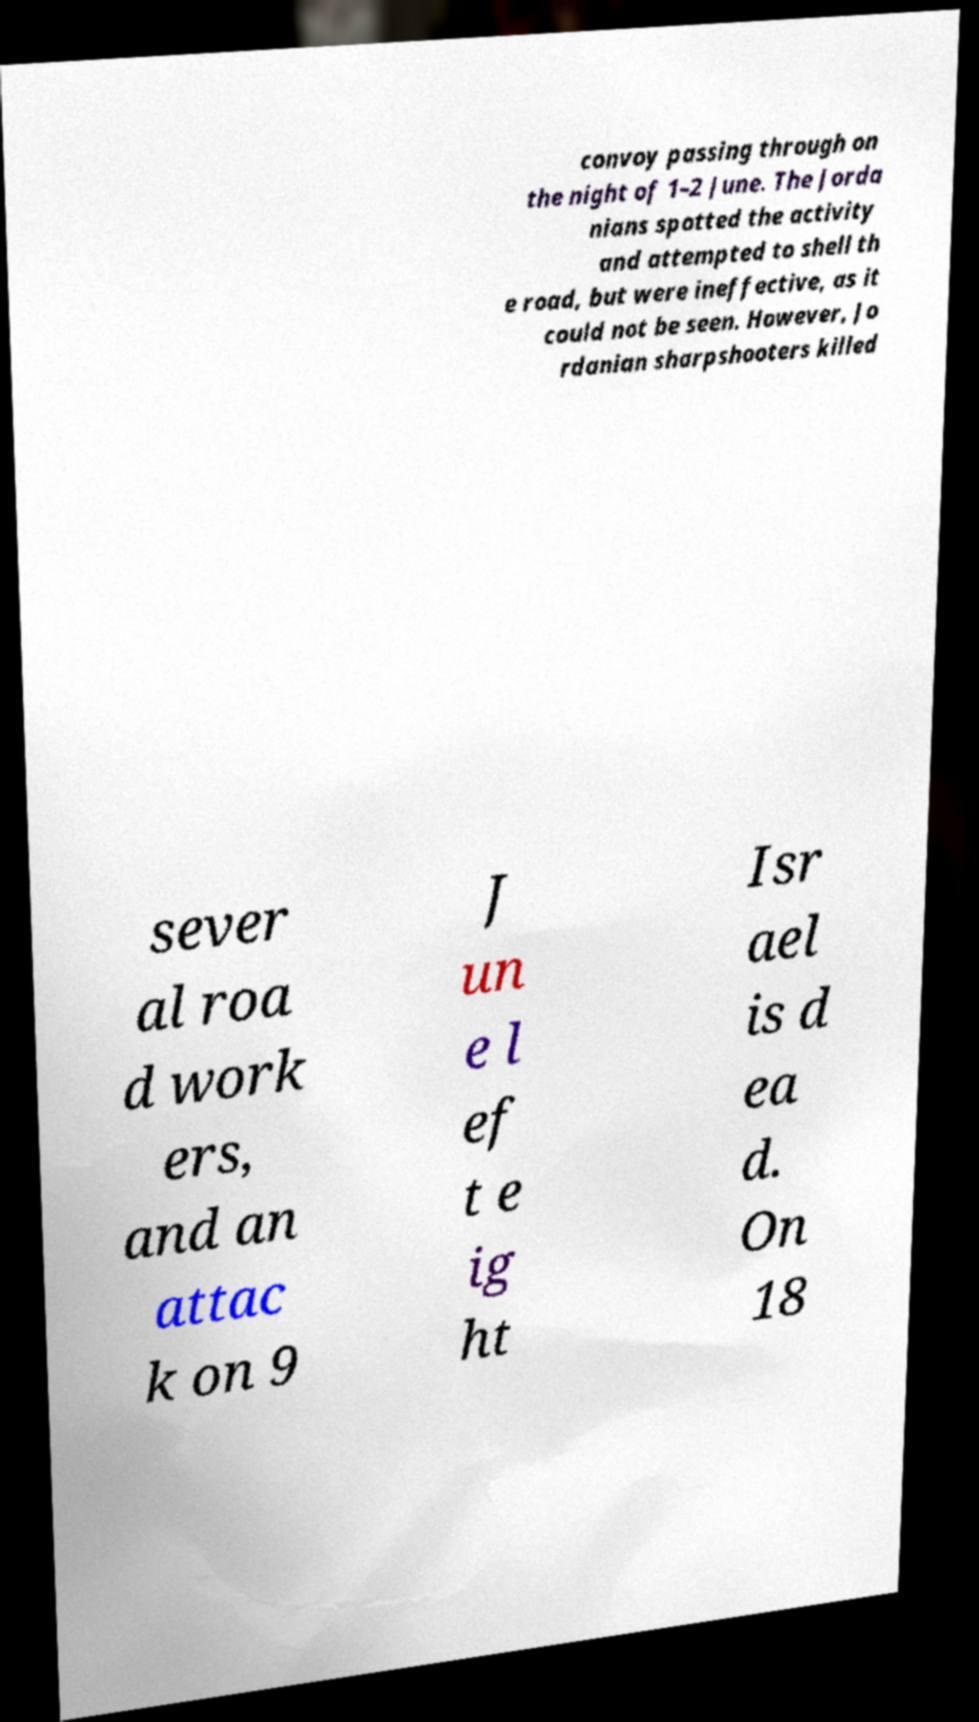Please identify and transcribe the text found in this image. convoy passing through on the night of 1–2 June. The Jorda nians spotted the activity and attempted to shell th e road, but were ineffective, as it could not be seen. However, Jo rdanian sharpshooters killed sever al roa d work ers, and an attac k on 9 J un e l ef t e ig ht Isr ael is d ea d. On 18 